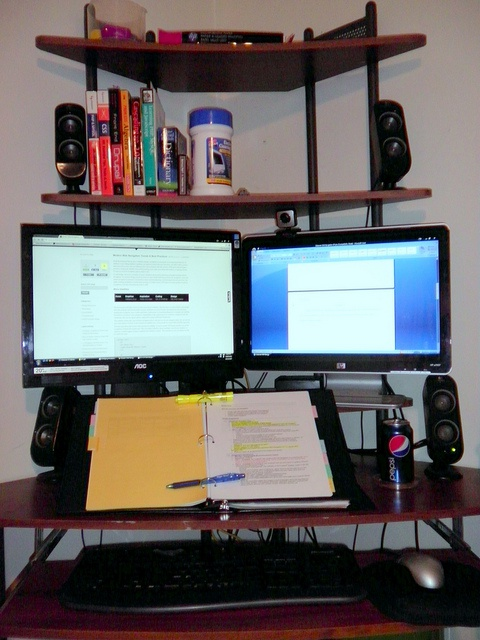Describe the objects in this image and their specific colors. I can see tv in gray, lightblue, black, and darkgray tones, book in gray, tan, darkgray, and black tones, tv in gray, lightblue, and black tones, keyboard in gray and black tones, and book in gray, teal, and darkgray tones in this image. 